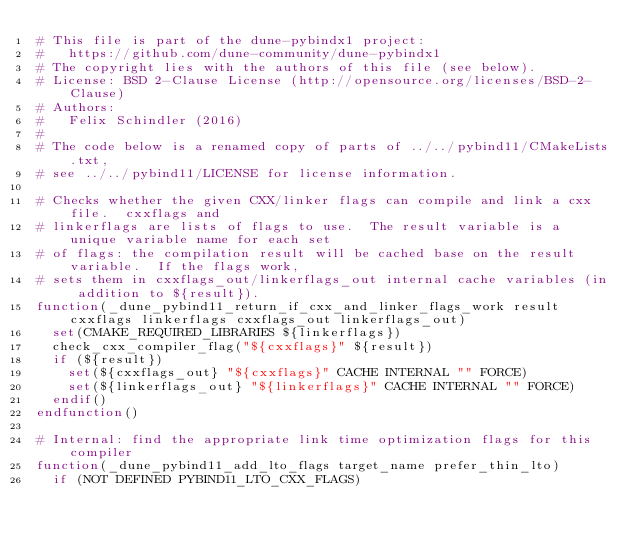<code> <loc_0><loc_0><loc_500><loc_500><_CMake_># This file is part of the dune-pybindx1 project:
#   https://github.com/dune-community/dune-pybindx1
# The copyright lies with the authors of this file (see below).
# License: BSD 2-Clause License (http://opensource.org/licenses/BSD-2-Clause)
# Authors:
#   Felix Schindler (2016)
#
# The code below is a renamed copy of parts of ../../pybind11/CMakeLists.txt,
# see ../../pybind11/LICENSE for license information.

# Checks whether the given CXX/linker flags can compile and link a cxx file.  cxxflags and
# linkerflags are lists of flags to use.  The result variable is a unique variable name for each set
# of flags: the compilation result will be cached base on the result variable.  If the flags work,
# sets them in cxxflags_out/linkerflags_out internal cache variables (in addition to ${result}).
function(_dune_pybind11_return_if_cxx_and_linker_flags_work result cxxflags linkerflags cxxflags_out linkerflags_out)
  set(CMAKE_REQUIRED_LIBRARIES ${linkerflags})
  check_cxx_compiler_flag("${cxxflags}" ${result})
  if (${result})
    set(${cxxflags_out} "${cxxflags}" CACHE INTERNAL "" FORCE)
    set(${linkerflags_out} "${linkerflags}" CACHE INTERNAL "" FORCE)
  endif()
endfunction()

# Internal: find the appropriate link time optimization flags for this compiler
function(_dune_pybind11_add_lto_flags target_name prefer_thin_lto)
  if (NOT DEFINED PYBIND11_LTO_CXX_FLAGS)</code> 